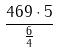<formula> <loc_0><loc_0><loc_500><loc_500>\frac { 4 6 9 \cdot 5 } { \frac { 6 } { 4 } }</formula> 